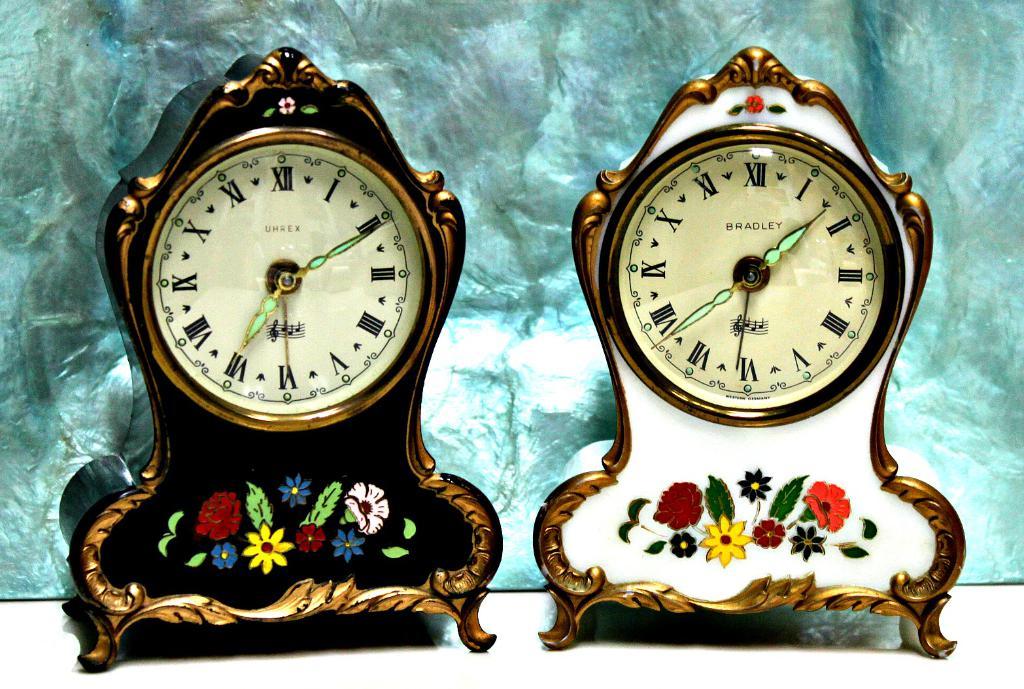What is the brand name of the clock on the right?
Offer a very short reply. Bradley. What is the time according to the black clock?
Provide a short and direct response. 7:10. 